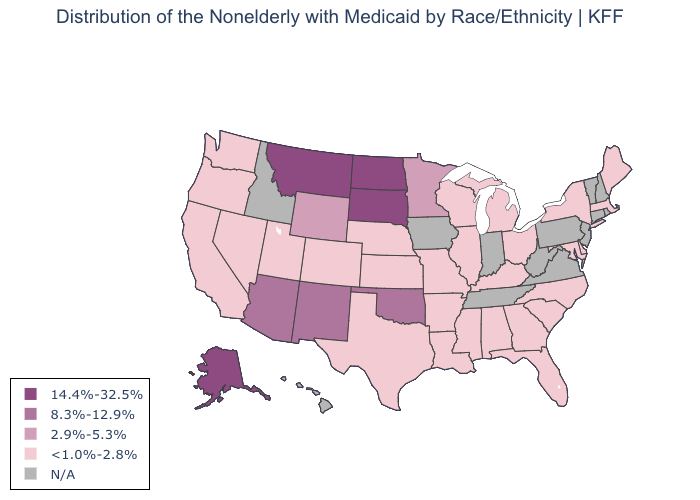What is the lowest value in states that border Arkansas?
Keep it brief. <1.0%-2.8%. Is the legend a continuous bar?
Be succinct. No. What is the lowest value in the MidWest?
Give a very brief answer. <1.0%-2.8%. Which states hav the highest value in the South?
Answer briefly. Oklahoma. Among the states that border North Dakota , which have the highest value?
Short answer required. Montana, South Dakota. Which states have the highest value in the USA?
Short answer required. Alaska, Montana, North Dakota, South Dakota. What is the value of Massachusetts?
Keep it brief. <1.0%-2.8%. Does the first symbol in the legend represent the smallest category?
Give a very brief answer. No. What is the value of Utah?
Keep it brief. <1.0%-2.8%. What is the value of Connecticut?
Answer briefly. N/A. Name the states that have a value in the range 14.4%-32.5%?
Give a very brief answer. Alaska, Montana, North Dakota, South Dakota. Among the states that border New Mexico , does Oklahoma have the lowest value?
Short answer required. No. Does Arkansas have the highest value in the South?
Write a very short answer. No. Does Arizona have the lowest value in the USA?
Answer briefly. No. 